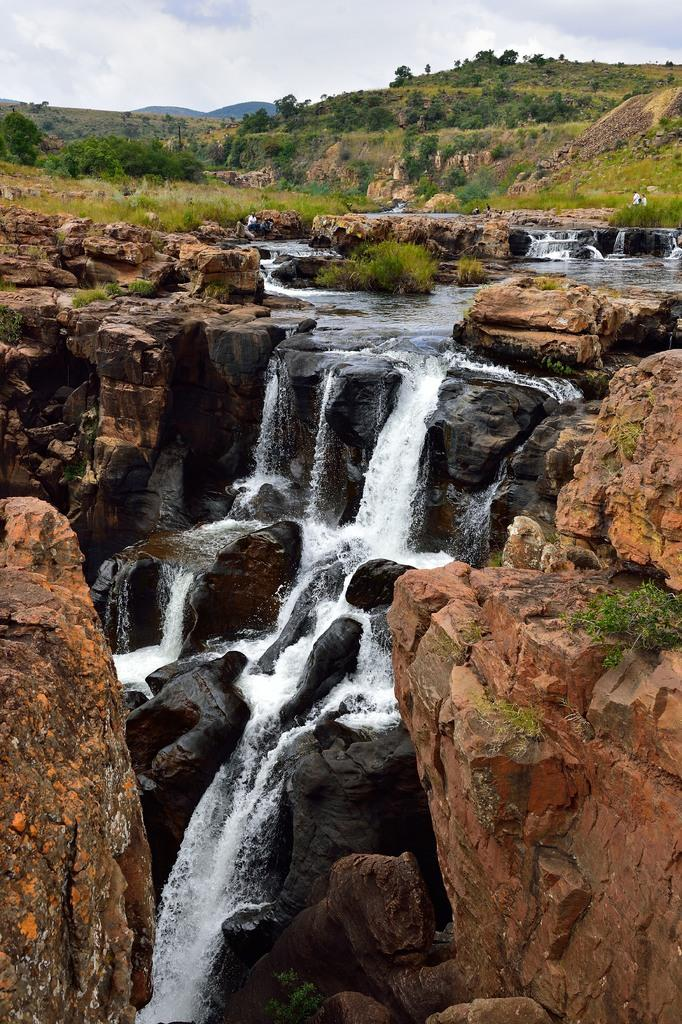What natural feature is the main subject of the image? There is a waterfall in the image. What other elements can be seen in the image? There are rocks, trees, and hills visible in the image. What is visible in the background of the image? The sky is visible in the background of the image. What type of guitar can be seen floating in the waterfall in the image? There is no guitar present in the image; it features a waterfall, rocks, trees, hills, and the sky. Can you tell me how many vessels are visible in the waterfall in the image? There are no vessels present in the image; it features a waterfall, rocks, trees, hills, and the sky. 